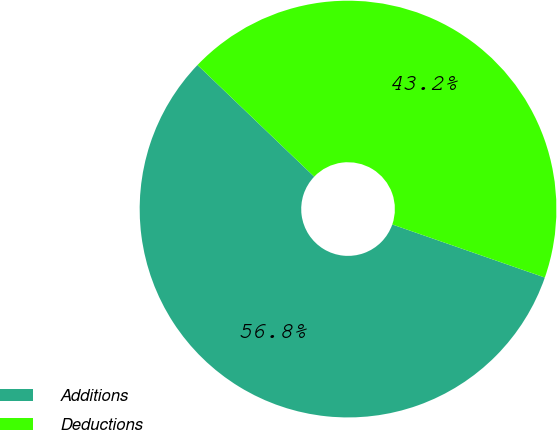Convert chart to OTSL. <chart><loc_0><loc_0><loc_500><loc_500><pie_chart><fcel>Additions<fcel>Deductions<nl><fcel>56.82%<fcel>43.18%<nl></chart> 